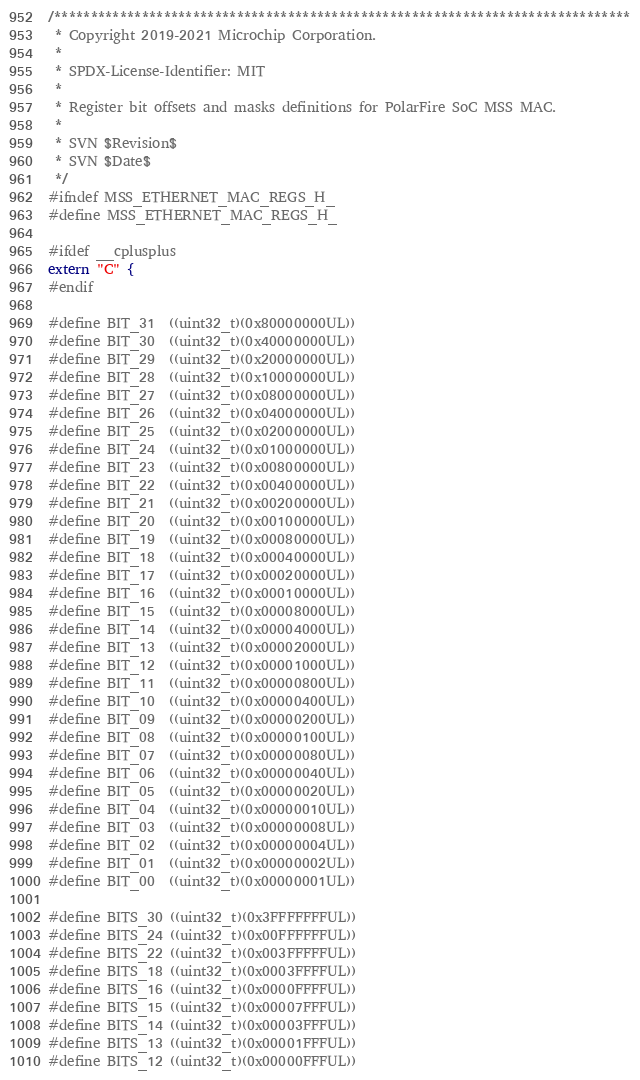Convert code to text. <code><loc_0><loc_0><loc_500><loc_500><_C_>/*******************************************************************************
 * Copyright 2019-2021 Microchip Corporation.
 *
 * SPDX-License-Identifier: MIT
 *
 * Register bit offsets and masks definitions for PolarFire SoC MSS MAC.
 *
 * SVN $Revision$
 * SVN $Date$
 */
#ifndef MSS_ETHERNET_MAC_REGS_H_
#define MSS_ETHERNET_MAC_REGS_H_

#ifdef __cplusplus
extern "C" {
#endif

#define BIT_31  ((uint32_t)(0x80000000UL))
#define BIT_30  ((uint32_t)(0x40000000UL))
#define BIT_29  ((uint32_t)(0x20000000UL))
#define BIT_28  ((uint32_t)(0x10000000UL))
#define BIT_27  ((uint32_t)(0x08000000UL))
#define BIT_26  ((uint32_t)(0x04000000UL))
#define BIT_25  ((uint32_t)(0x02000000UL))
#define BIT_24  ((uint32_t)(0x01000000UL))
#define BIT_23  ((uint32_t)(0x00800000UL))
#define BIT_22  ((uint32_t)(0x00400000UL))
#define BIT_21  ((uint32_t)(0x00200000UL))
#define BIT_20  ((uint32_t)(0x00100000UL))
#define BIT_19  ((uint32_t)(0x00080000UL))
#define BIT_18  ((uint32_t)(0x00040000UL))
#define BIT_17  ((uint32_t)(0x00020000UL))
#define BIT_16  ((uint32_t)(0x00010000UL))
#define BIT_15  ((uint32_t)(0x00008000UL))
#define BIT_14  ((uint32_t)(0x00004000UL))
#define BIT_13  ((uint32_t)(0x00002000UL))
#define BIT_12  ((uint32_t)(0x00001000UL))
#define BIT_11  ((uint32_t)(0x00000800UL))
#define BIT_10  ((uint32_t)(0x00000400UL))
#define BIT_09  ((uint32_t)(0x00000200UL))
#define BIT_08  ((uint32_t)(0x00000100UL))
#define BIT_07  ((uint32_t)(0x00000080UL))
#define BIT_06  ((uint32_t)(0x00000040UL))
#define BIT_05  ((uint32_t)(0x00000020UL))
#define BIT_04  ((uint32_t)(0x00000010UL))
#define BIT_03  ((uint32_t)(0x00000008UL))
#define BIT_02  ((uint32_t)(0x00000004UL))
#define BIT_01  ((uint32_t)(0x00000002UL))
#define BIT_00  ((uint32_t)(0x00000001UL))

#define BITS_30 ((uint32_t)(0x3FFFFFFFUL))
#define BITS_24 ((uint32_t)(0x00FFFFFFUL))
#define BITS_22 ((uint32_t)(0x003FFFFFUL))
#define BITS_18 ((uint32_t)(0x0003FFFFUL))
#define BITS_16 ((uint32_t)(0x0000FFFFUL))
#define BITS_15 ((uint32_t)(0x00007FFFUL))
#define BITS_14 ((uint32_t)(0x00003FFFUL))
#define BITS_13 ((uint32_t)(0x00001FFFUL))
#define BITS_12 ((uint32_t)(0x00000FFFUL))</code> 